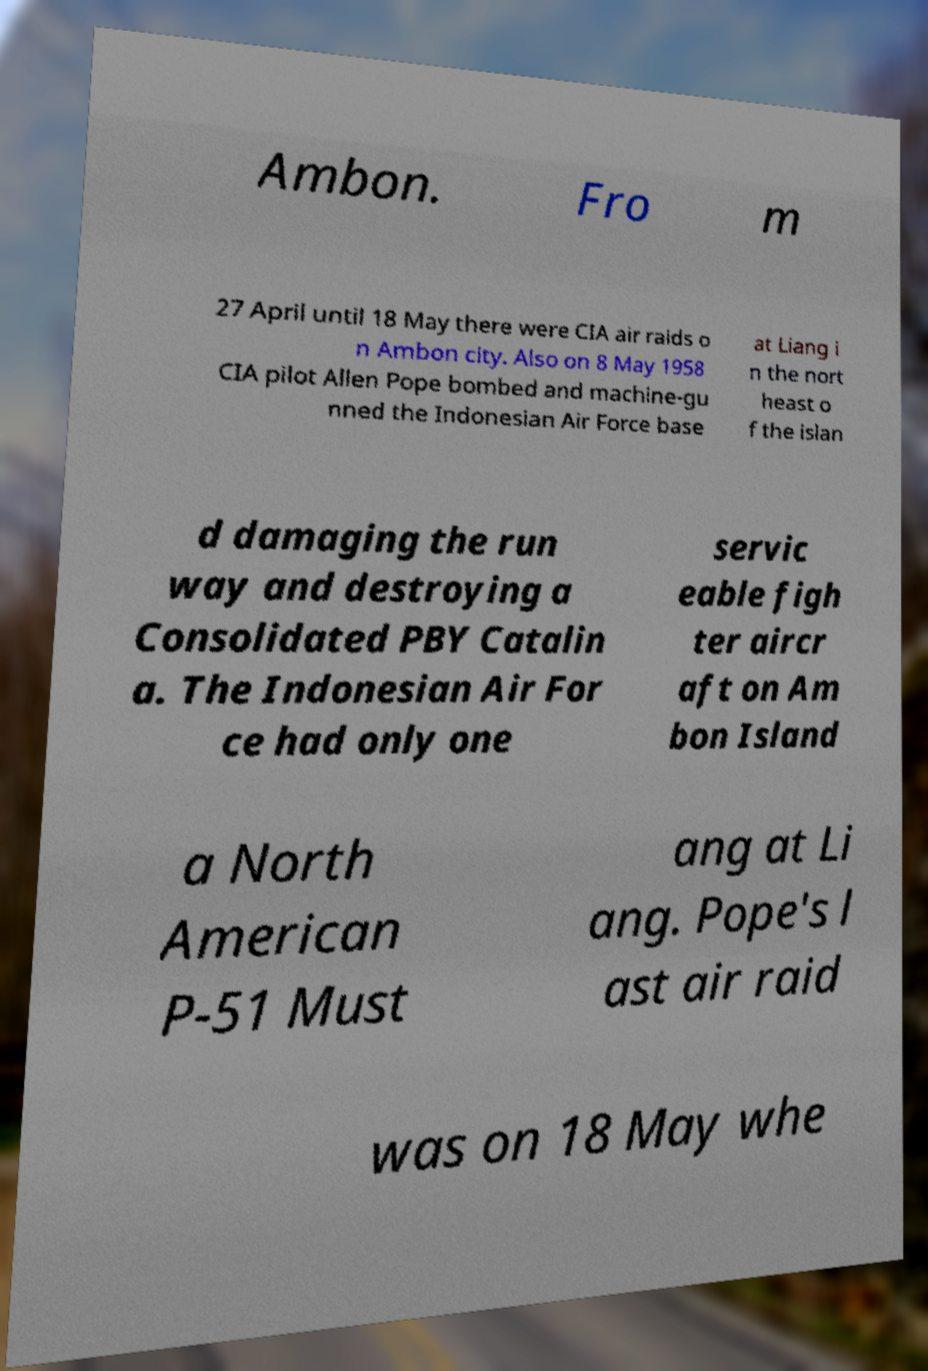What messages or text are displayed in this image? I need them in a readable, typed format. Ambon. Fro m 27 April until 18 May there were CIA air raids o n Ambon city. Also on 8 May 1958 CIA pilot Allen Pope bombed and machine-gu nned the Indonesian Air Force base at Liang i n the nort heast o f the islan d damaging the run way and destroying a Consolidated PBY Catalin a. The Indonesian Air For ce had only one servic eable figh ter aircr aft on Am bon Island a North American P-51 Must ang at Li ang. Pope's l ast air raid was on 18 May whe 